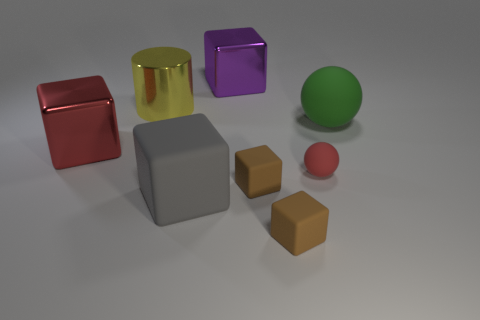Does the small ball have the same color as the large metal block to the left of the yellow thing?
Offer a terse response. Yes. How many big shiny objects have the same color as the tiny ball?
Your answer should be compact. 1. There is a matte thing that is on the right side of the red thing in front of the big red shiny block; is there a red sphere that is to the right of it?
Your answer should be compact. No. Are there more blocks that are on the left side of the large green sphere than red cubes behind the purple metallic object?
Ensure brevity in your answer.  Yes. There is a green ball that is the same size as the red block; what is it made of?
Ensure brevity in your answer.  Rubber. What number of tiny objects are purple cylinders or brown rubber objects?
Give a very brief answer. 2. Does the large red object have the same shape as the large purple metal object?
Keep it short and to the point. Yes. What number of large objects are on the right side of the large red shiny thing and in front of the big green rubber thing?
Your answer should be very brief. 1. Is there any other thing of the same color as the small ball?
Your response must be concise. Yes. The gray object that is the same material as the big ball is what shape?
Provide a short and direct response. Cube. 